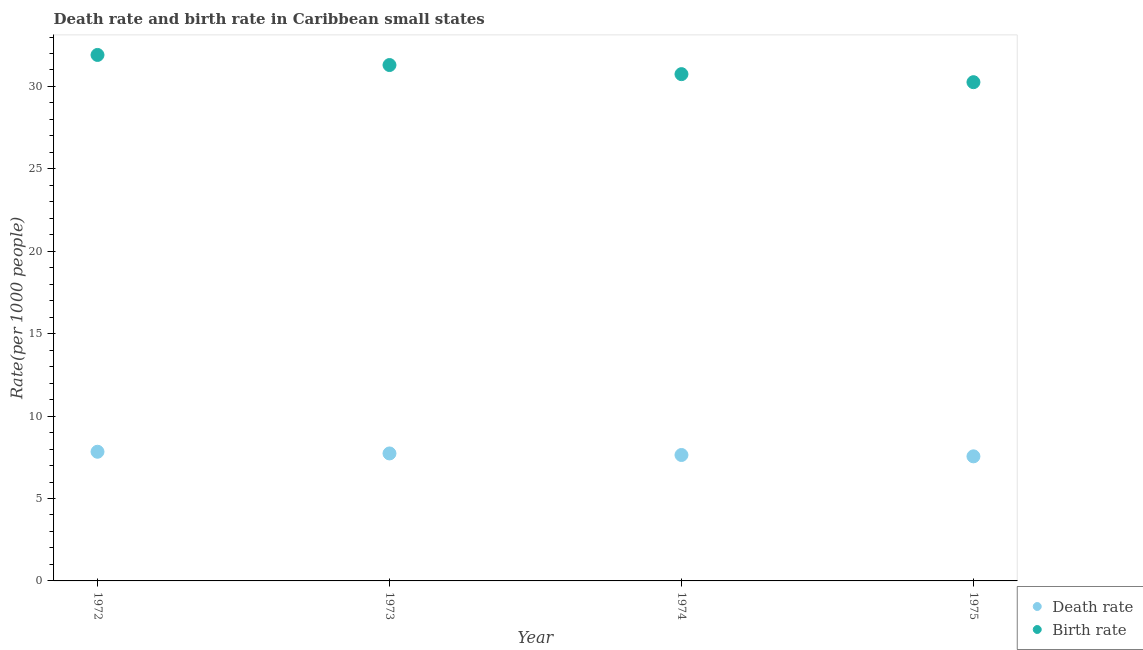What is the birth rate in 1972?
Your answer should be very brief. 31.91. Across all years, what is the maximum birth rate?
Provide a short and direct response. 31.91. Across all years, what is the minimum death rate?
Give a very brief answer. 7.56. In which year was the birth rate maximum?
Make the answer very short. 1972. In which year was the birth rate minimum?
Offer a very short reply. 1975. What is the total birth rate in the graph?
Provide a succinct answer. 124.22. What is the difference between the death rate in 1972 and that in 1973?
Keep it short and to the point. 0.1. What is the difference between the birth rate in 1972 and the death rate in 1974?
Make the answer very short. 24.27. What is the average birth rate per year?
Your answer should be compact. 31.05. In the year 1973, what is the difference between the birth rate and death rate?
Give a very brief answer. 23.57. What is the ratio of the birth rate in 1972 to that in 1975?
Provide a short and direct response. 1.05. Is the death rate in 1973 less than that in 1974?
Your response must be concise. No. What is the difference between the highest and the second highest death rate?
Your answer should be compact. 0.1. What is the difference between the highest and the lowest death rate?
Provide a succinct answer. 0.28. In how many years, is the death rate greater than the average death rate taken over all years?
Provide a short and direct response. 2. Is the sum of the death rate in 1972 and 1974 greater than the maximum birth rate across all years?
Make the answer very short. No. Does the birth rate monotonically increase over the years?
Make the answer very short. No. Is the death rate strictly greater than the birth rate over the years?
Offer a very short reply. No. How many years are there in the graph?
Provide a short and direct response. 4. What is the difference between two consecutive major ticks on the Y-axis?
Ensure brevity in your answer.  5. Where does the legend appear in the graph?
Provide a succinct answer. Bottom right. How are the legend labels stacked?
Offer a very short reply. Vertical. What is the title of the graph?
Give a very brief answer. Death rate and birth rate in Caribbean small states. What is the label or title of the Y-axis?
Offer a very short reply. Rate(per 1000 people). What is the Rate(per 1000 people) in Death rate in 1972?
Ensure brevity in your answer.  7.84. What is the Rate(per 1000 people) in Birth rate in 1972?
Provide a short and direct response. 31.91. What is the Rate(per 1000 people) of Death rate in 1973?
Offer a terse response. 7.73. What is the Rate(per 1000 people) of Birth rate in 1973?
Make the answer very short. 31.3. What is the Rate(per 1000 people) of Death rate in 1974?
Offer a very short reply. 7.64. What is the Rate(per 1000 people) in Birth rate in 1974?
Give a very brief answer. 30.75. What is the Rate(per 1000 people) in Death rate in 1975?
Keep it short and to the point. 7.56. What is the Rate(per 1000 people) in Birth rate in 1975?
Your answer should be very brief. 30.26. Across all years, what is the maximum Rate(per 1000 people) of Death rate?
Offer a very short reply. 7.84. Across all years, what is the maximum Rate(per 1000 people) of Birth rate?
Your answer should be very brief. 31.91. Across all years, what is the minimum Rate(per 1000 people) of Death rate?
Ensure brevity in your answer.  7.56. Across all years, what is the minimum Rate(per 1000 people) in Birth rate?
Your answer should be compact. 30.26. What is the total Rate(per 1000 people) of Death rate in the graph?
Keep it short and to the point. 30.77. What is the total Rate(per 1000 people) of Birth rate in the graph?
Offer a terse response. 124.22. What is the difference between the Rate(per 1000 people) in Death rate in 1972 and that in 1973?
Give a very brief answer. 0.1. What is the difference between the Rate(per 1000 people) in Birth rate in 1972 and that in 1973?
Give a very brief answer. 0.61. What is the difference between the Rate(per 1000 people) in Death rate in 1972 and that in 1974?
Provide a short and direct response. 0.2. What is the difference between the Rate(per 1000 people) in Birth rate in 1972 and that in 1974?
Provide a short and direct response. 1.16. What is the difference between the Rate(per 1000 people) in Death rate in 1972 and that in 1975?
Keep it short and to the point. 0.28. What is the difference between the Rate(per 1000 people) of Birth rate in 1972 and that in 1975?
Offer a terse response. 1.65. What is the difference between the Rate(per 1000 people) of Death rate in 1973 and that in 1974?
Keep it short and to the point. 0.09. What is the difference between the Rate(per 1000 people) of Birth rate in 1973 and that in 1974?
Your response must be concise. 0.55. What is the difference between the Rate(per 1000 people) of Death rate in 1973 and that in 1975?
Offer a very short reply. 0.18. What is the difference between the Rate(per 1000 people) in Birth rate in 1973 and that in 1975?
Ensure brevity in your answer.  1.04. What is the difference between the Rate(per 1000 people) of Death rate in 1974 and that in 1975?
Your response must be concise. 0.08. What is the difference between the Rate(per 1000 people) of Birth rate in 1974 and that in 1975?
Give a very brief answer. 0.49. What is the difference between the Rate(per 1000 people) in Death rate in 1972 and the Rate(per 1000 people) in Birth rate in 1973?
Keep it short and to the point. -23.46. What is the difference between the Rate(per 1000 people) of Death rate in 1972 and the Rate(per 1000 people) of Birth rate in 1974?
Your answer should be compact. -22.91. What is the difference between the Rate(per 1000 people) in Death rate in 1972 and the Rate(per 1000 people) in Birth rate in 1975?
Ensure brevity in your answer.  -22.42. What is the difference between the Rate(per 1000 people) of Death rate in 1973 and the Rate(per 1000 people) of Birth rate in 1974?
Your answer should be compact. -23.01. What is the difference between the Rate(per 1000 people) in Death rate in 1973 and the Rate(per 1000 people) in Birth rate in 1975?
Give a very brief answer. -22.52. What is the difference between the Rate(per 1000 people) in Death rate in 1974 and the Rate(per 1000 people) in Birth rate in 1975?
Keep it short and to the point. -22.62. What is the average Rate(per 1000 people) of Death rate per year?
Your answer should be compact. 7.69. What is the average Rate(per 1000 people) in Birth rate per year?
Offer a terse response. 31.05. In the year 1972, what is the difference between the Rate(per 1000 people) in Death rate and Rate(per 1000 people) in Birth rate?
Provide a short and direct response. -24.07. In the year 1973, what is the difference between the Rate(per 1000 people) in Death rate and Rate(per 1000 people) in Birth rate?
Give a very brief answer. -23.57. In the year 1974, what is the difference between the Rate(per 1000 people) of Death rate and Rate(per 1000 people) of Birth rate?
Your answer should be compact. -23.11. In the year 1975, what is the difference between the Rate(per 1000 people) in Death rate and Rate(per 1000 people) in Birth rate?
Ensure brevity in your answer.  -22.7. What is the ratio of the Rate(per 1000 people) of Death rate in 1972 to that in 1973?
Your response must be concise. 1.01. What is the ratio of the Rate(per 1000 people) in Birth rate in 1972 to that in 1973?
Your answer should be very brief. 1.02. What is the ratio of the Rate(per 1000 people) in Death rate in 1972 to that in 1974?
Offer a terse response. 1.03. What is the ratio of the Rate(per 1000 people) of Birth rate in 1972 to that in 1974?
Your response must be concise. 1.04. What is the ratio of the Rate(per 1000 people) in Death rate in 1972 to that in 1975?
Offer a terse response. 1.04. What is the ratio of the Rate(per 1000 people) in Birth rate in 1972 to that in 1975?
Ensure brevity in your answer.  1.05. What is the ratio of the Rate(per 1000 people) of Death rate in 1973 to that in 1974?
Your answer should be very brief. 1.01. What is the ratio of the Rate(per 1000 people) of Death rate in 1973 to that in 1975?
Your answer should be very brief. 1.02. What is the ratio of the Rate(per 1000 people) of Birth rate in 1973 to that in 1975?
Keep it short and to the point. 1.03. What is the ratio of the Rate(per 1000 people) in Death rate in 1974 to that in 1975?
Provide a succinct answer. 1.01. What is the ratio of the Rate(per 1000 people) of Birth rate in 1974 to that in 1975?
Keep it short and to the point. 1.02. What is the difference between the highest and the second highest Rate(per 1000 people) of Death rate?
Provide a short and direct response. 0.1. What is the difference between the highest and the second highest Rate(per 1000 people) of Birth rate?
Make the answer very short. 0.61. What is the difference between the highest and the lowest Rate(per 1000 people) in Death rate?
Your answer should be compact. 0.28. What is the difference between the highest and the lowest Rate(per 1000 people) of Birth rate?
Provide a succinct answer. 1.65. 